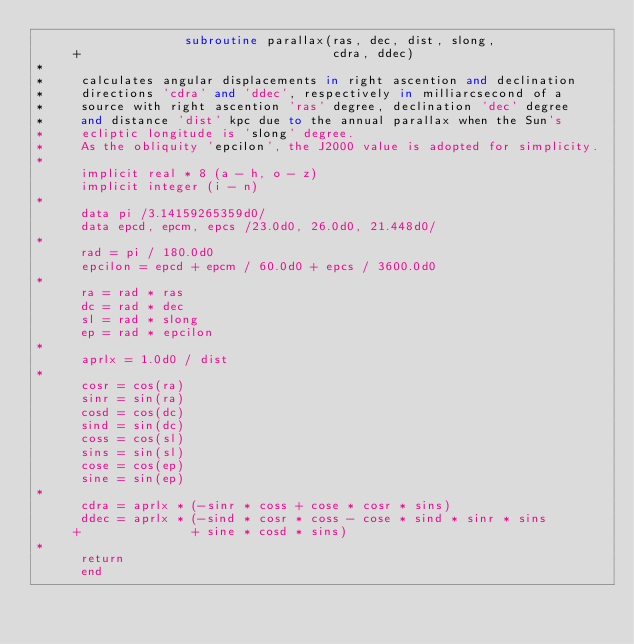<code> <loc_0><loc_0><loc_500><loc_500><_FORTRAN_>                    subroutine parallax(ras, dec, dist, slong,
     +                                  cdra, ddec)
*
*     calculates angular displacements in right ascention and declination
*     directions 'cdra' and 'ddec', respectively in milliarcsecond of a 
*     source with right ascention 'ras' degree, declination 'dec' degree 
*     and distance 'dist' kpc due to the annual parallax when the Sun's 
*     ecliptic longitude is 'slong' degree. 
*     As the obliquity 'epcilon', the J2000 value is adopted for simplicity.
*
      implicit real * 8 (a - h, o - z)
      implicit integer (i - n)
*
      data pi /3.14159265359d0/
      data epcd, epcm, epcs /23.0d0, 26.0d0, 21.448d0/
*
      rad = pi / 180.0d0
      epcilon = epcd + epcm / 60.0d0 + epcs / 3600.0d0
*
      ra = rad * ras
      dc = rad * dec
      sl = rad * slong
      ep = rad * epcilon
*
      aprlx = 1.0d0 / dist
*
      cosr = cos(ra)
      sinr = sin(ra)
      cosd = cos(dc)
      sind = sin(dc)
      coss = cos(sl)
      sins = sin(sl)
      cose = cos(ep)
      sine = sin(ep)
*
      cdra = aprlx * (-sinr * coss + cose * cosr * sins)
      ddec = aprlx * (-sind * cosr * coss - cose * sind * sinr * sins
     +               + sine * cosd * sins)
*
      return
      end
</code> 